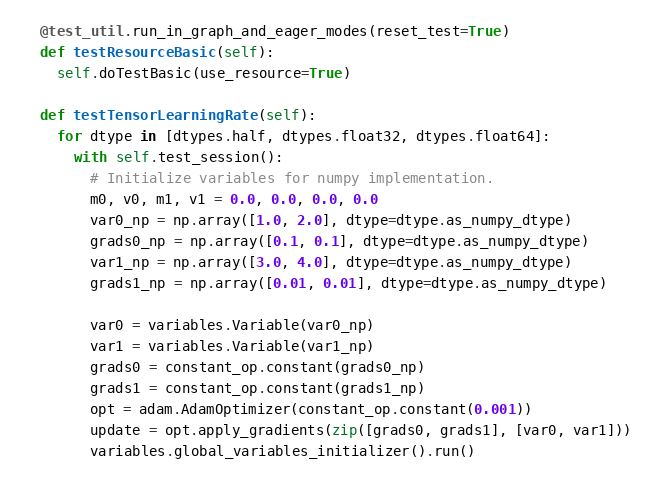<code> <loc_0><loc_0><loc_500><loc_500><_Python_>
  @test_util.run_in_graph_and_eager_modes(reset_test=True)
  def testResourceBasic(self):
    self.doTestBasic(use_resource=True)

  def testTensorLearningRate(self):
    for dtype in [dtypes.half, dtypes.float32, dtypes.float64]:
      with self.test_session():
        # Initialize variables for numpy implementation.
        m0, v0, m1, v1 = 0.0, 0.0, 0.0, 0.0
        var0_np = np.array([1.0, 2.0], dtype=dtype.as_numpy_dtype)
        grads0_np = np.array([0.1, 0.1], dtype=dtype.as_numpy_dtype)
        var1_np = np.array([3.0, 4.0], dtype=dtype.as_numpy_dtype)
        grads1_np = np.array([0.01, 0.01], dtype=dtype.as_numpy_dtype)

        var0 = variables.Variable(var0_np)
        var1 = variables.Variable(var1_np)
        grads0 = constant_op.constant(grads0_np)
        grads1 = constant_op.constant(grads1_np)
        opt = adam.AdamOptimizer(constant_op.constant(0.001))
        update = opt.apply_gradients(zip([grads0, grads1], [var0, var1]))
        variables.global_variables_initializer().run()
</code> 